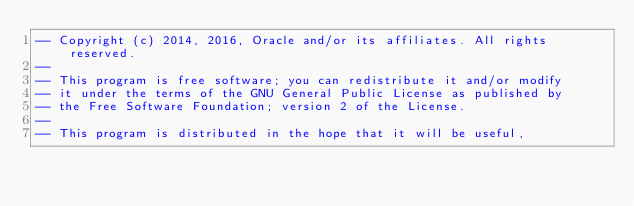Convert code to text. <code><loc_0><loc_0><loc_500><loc_500><_SQL_>-- Copyright (c) 2014, 2016, Oracle and/or its affiliates. All rights reserved.
--
-- This program is free software; you can redistribute it and/or modify
-- it under the terms of the GNU General Public License as published by
-- the Free Software Foundation; version 2 of the License.
--
-- This program is distributed in the hope that it will be useful,</code> 